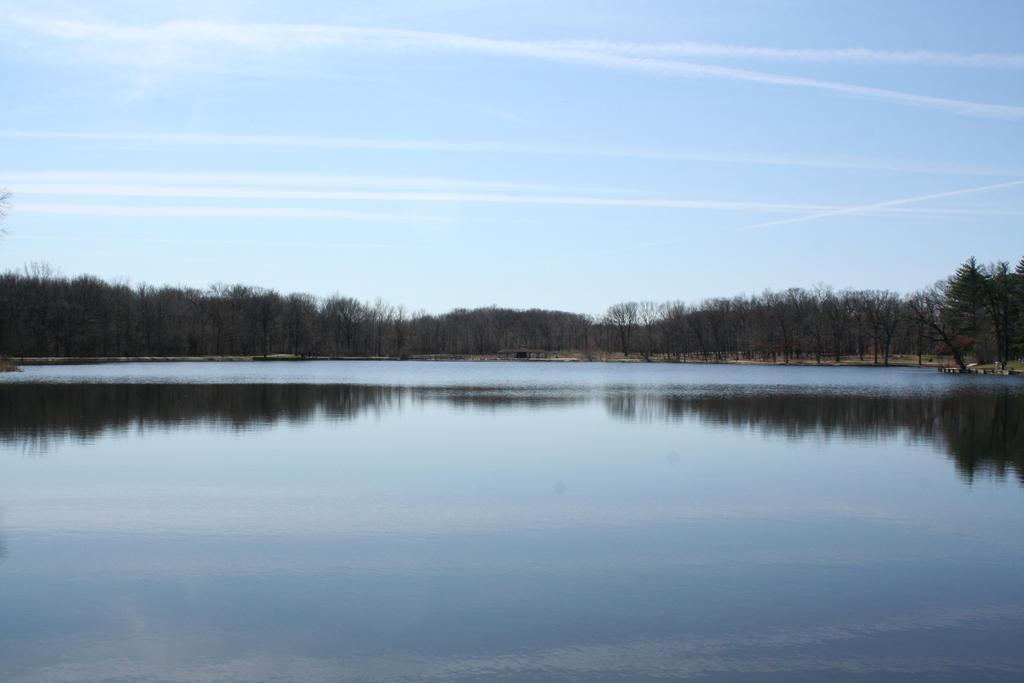Could you give a brief overview of what you see in this image? In this image we can see a lake, trees and sky with clouds. 